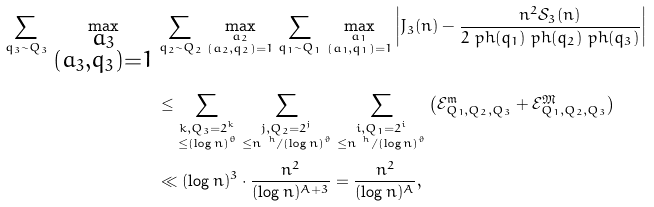Convert formula to latex. <formula><loc_0><loc_0><loc_500><loc_500>\sum _ { q _ { 3 } \sim Q _ { 3 } } \, \max _ { \substack { a _ { 3 } \\ ( a _ { 3 } , q _ { 3 } ) = 1 } } \, & \sum _ { q _ { 2 } \sim Q _ { 2 } } \, \max _ { \substack { a _ { 2 } \\ ( a _ { 2 } , q _ { 2 } ) = 1 } } \, \sum _ { q _ { 1 } \sim Q _ { 1 } } \, \max _ { \substack { a _ { 1 } \\ ( a _ { 1 } , q _ { 1 } ) = 1 } } \left | J _ { 3 } ( n ) - \frac { n ^ { 2 } \mathcal { S } _ { 3 } ( n ) } { 2 \ p h ( q _ { 1 } ) \ p h ( q _ { 2 } ) \ p h ( q _ { 3 } ) } \right | \\ & \leq \sum _ { \substack { k , Q _ { 3 } = 2 ^ { k } \\ \leq ( \log n ) ^ { \theta } } } \, \sum _ { \substack { j , Q _ { 2 } = 2 ^ { j } \\ \leq n ^ { \ h } / ( \log n ) ^ { \vartheta } } } \, \sum _ { \substack { i , Q _ { 1 } = 2 ^ { i } \\ \leq n ^ { \ h } / ( \log n ) ^ { \vartheta } } } \left ( \mathcal { E } _ { Q _ { 1 } , Q _ { 2 } , Q _ { 3 } } ^ { \mathfrak { m } } + \mathcal { E } _ { Q _ { 1 } , Q _ { 2 } , Q _ { 3 } } ^ { \mathfrak { M } } \right ) \\ & \ll ( \log n ) ^ { 3 } \cdot \frac { n ^ { 2 } } { ( \log n ) ^ { A + 3 } } = \frac { n ^ { 2 } } { ( \log n ) ^ { A } } ,</formula> 